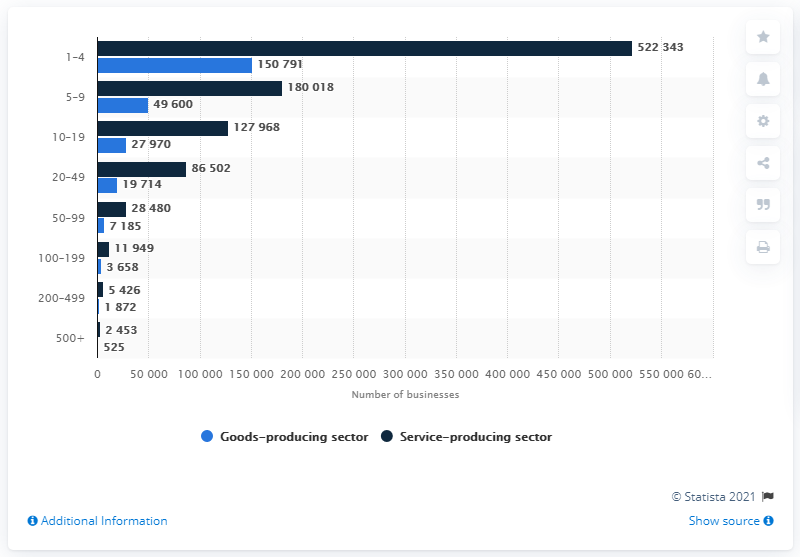Point out several critical features in this image. There were 525 goods-producing companies in Canada in December 2019. 